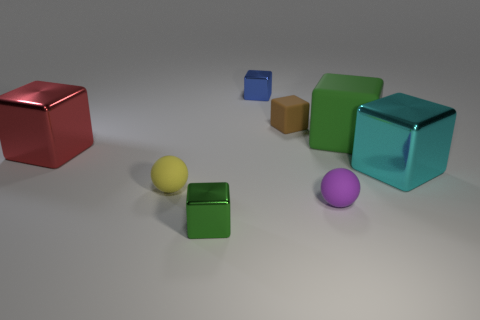Is there a purple cylinder that has the same material as the red cube?
Ensure brevity in your answer.  No. Is the material of the green object that is in front of the cyan thing the same as the green block that is behind the cyan shiny block?
Provide a succinct answer. No. What number of gray blocks are there?
Provide a short and direct response. 0. What is the shape of the green object behind the small green metallic cube?
Your response must be concise. Cube. How many other objects are there of the same size as the cyan block?
Your response must be concise. 2. There is a rubber thing that is left of the tiny green object; does it have the same shape as the big metal object that is right of the brown thing?
Your answer should be very brief. No. There is a big cyan metallic cube; how many big cyan blocks are in front of it?
Ensure brevity in your answer.  0. What is the color of the tiny rubber ball to the left of the purple rubber object?
Provide a short and direct response. Yellow. There is a tiny rubber thing that is the same shape as the cyan metal object; what color is it?
Give a very brief answer. Brown. Is there any other thing that has the same color as the tiny rubber block?
Your answer should be very brief. No. 